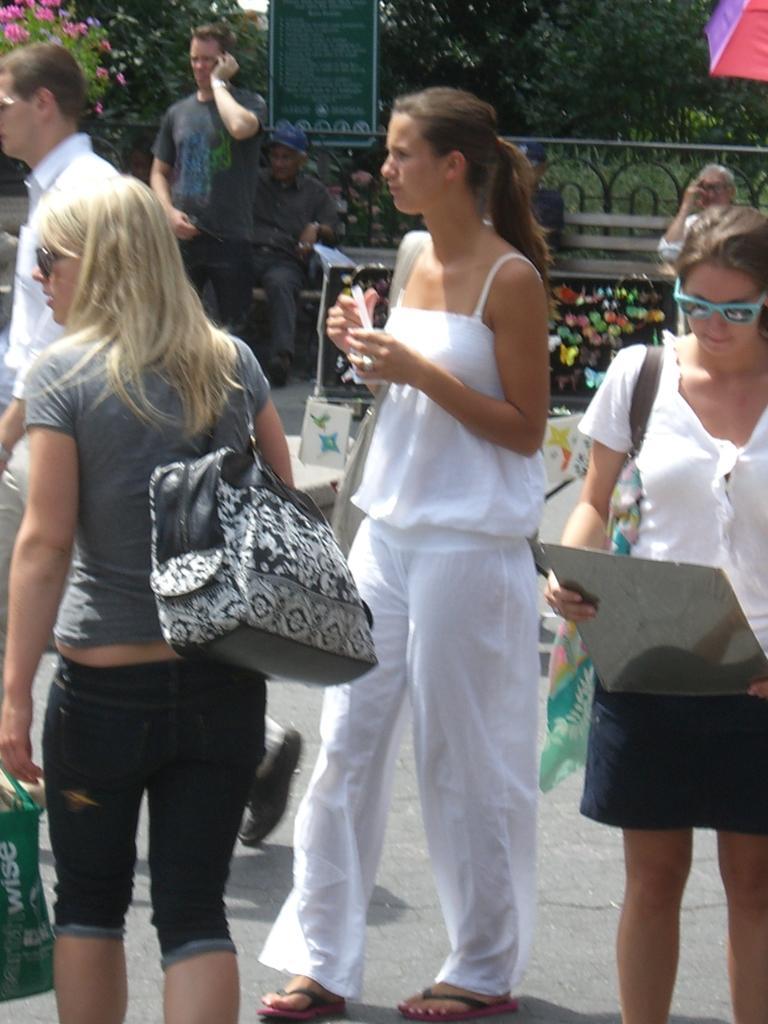Can you describe this image briefly? This picture is taken on the road side there are some people standing and in the background there is a man who is walking and a man talking on the phone, There are some green color trees. 